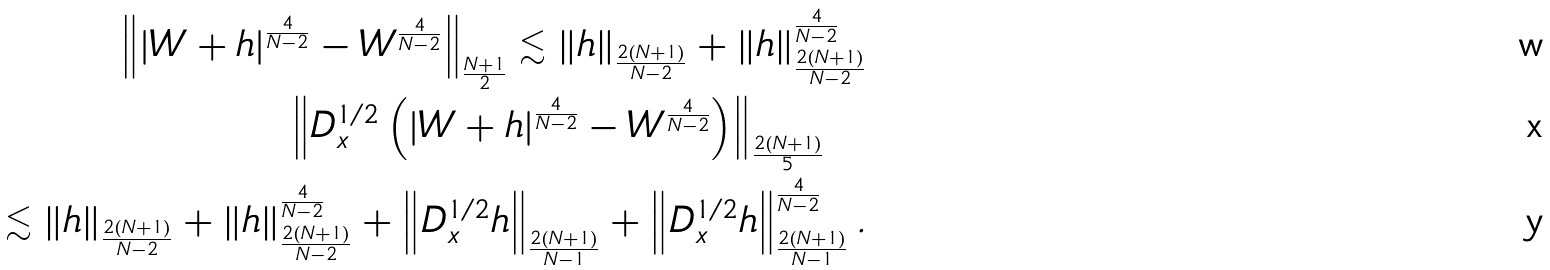Convert formula to latex. <formula><loc_0><loc_0><loc_500><loc_500>\left \| \left | W + h \right | ^ { \frac { 4 } { N - 2 } } - W ^ { \frac { 4 } { N - 2 } } \right \| _ { \frac { N + 1 } { 2 } } \lesssim \left \| h \right \| _ { \frac { 2 ( N + 1 ) } { N - 2 } } + \left \| h \right \| _ { \frac { 2 ( N + 1 ) } { N - 2 } } ^ { \frac { 4 } { N - 2 } } \\ \left \| D _ { x } ^ { 1 / 2 } \left ( \left | W + h \right | ^ { \frac { 4 } { N - 2 } } - W ^ { \frac { 4 } { N - 2 } } \right ) \right \| _ { \frac { 2 ( N + 1 ) } { 5 } } \quad \\ \quad \lesssim \left \| h \right \| _ { \frac { 2 ( N + 1 ) } { N - 2 } } + \left \| h \right \| _ { \frac { 2 ( N + 1 ) } { N - 2 } } ^ { \frac { 4 } { N - 2 } } + \left \| D _ { x } ^ { 1 / 2 } h \right \| _ { \frac { 2 ( N + 1 ) } { N - 1 } } + \left \| D _ { x } ^ { 1 / 2 } h \right \| _ { \frac { 2 ( N + 1 ) } { N - 1 } } ^ { \frac { 4 } { N - 2 } } .</formula> 